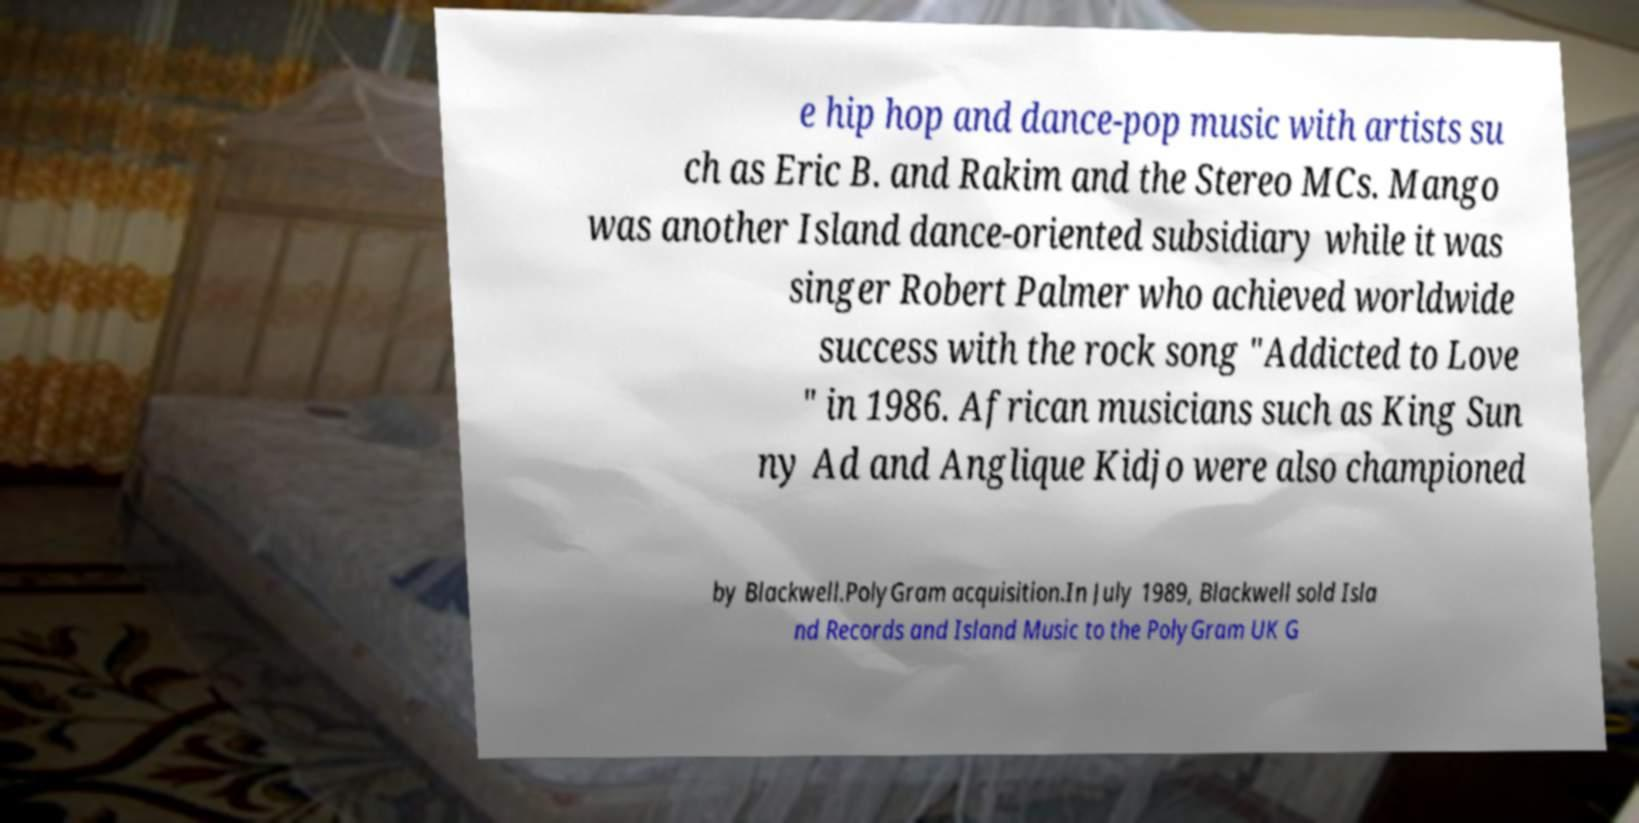What messages or text are displayed in this image? I need them in a readable, typed format. e hip hop and dance-pop music with artists su ch as Eric B. and Rakim and the Stereo MCs. Mango was another Island dance-oriented subsidiary while it was singer Robert Palmer who achieved worldwide success with the rock song "Addicted to Love " in 1986. African musicians such as King Sun ny Ad and Anglique Kidjo were also championed by Blackwell.PolyGram acquisition.In July 1989, Blackwell sold Isla nd Records and Island Music to the PolyGram UK G 